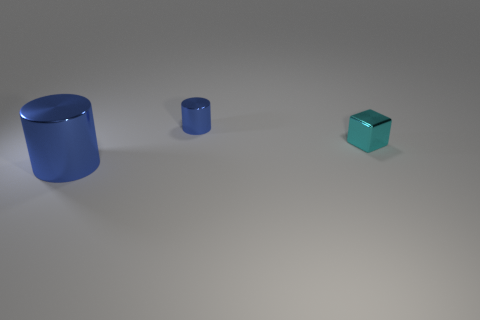There is a tiny thing that is in front of the blue cylinder that is behind the tiny thing in front of the tiny blue cylinder; what shape is it?
Provide a succinct answer. Cube. Do the blue object that is in front of the cyan metallic thing and the tiny thing right of the tiny blue shiny object have the same material?
Provide a short and direct response. Yes. What number of tiny matte things are the same shape as the large blue thing?
Your answer should be compact. 0. There is another cylinder that is the same color as the large shiny cylinder; what is its material?
Your answer should be compact. Metal. Is there any other thing that is the same shape as the small cyan metallic thing?
Provide a succinct answer. No. What is the color of the cylinder that is right of the blue cylinder that is in front of the blue object that is behind the large cylinder?
Give a very brief answer. Blue. What number of tiny things are cyan metallic objects or metal things?
Offer a terse response. 2. Is the number of things in front of the tiny blue cylinder the same as the number of blue cylinders?
Keep it short and to the point. Yes. Are there any metallic things left of the small cylinder?
Keep it short and to the point. Yes. How many rubber objects are big things or small blue cylinders?
Give a very brief answer. 0. 